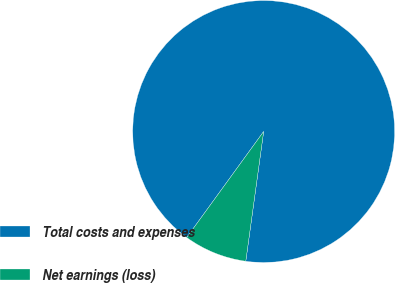Convert chart. <chart><loc_0><loc_0><loc_500><loc_500><pie_chart><fcel>Total costs and expenses<fcel>Net earnings (loss)<nl><fcel>92.19%<fcel>7.81%<nl></chart> 